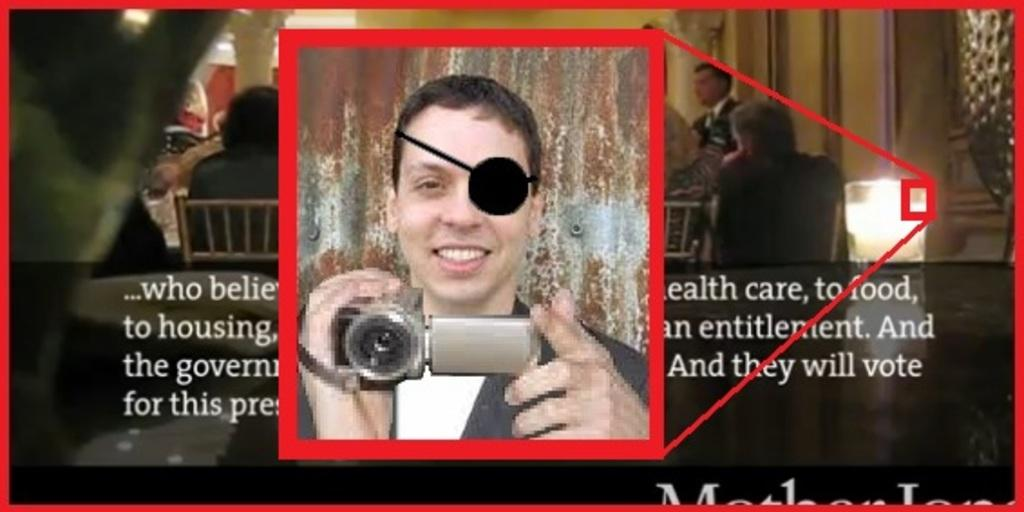What is the main object in the image? There is a poster in the image. What is depicted on the poster? The poster contains an image of a man holding a camera. Are there any other people visible in the image besides the man on the poster? Yes, there are people visible in the image. What else can be found on the poster besides the image of the man holding a camera? There is text on the poster. What type of turkey is being prepared by the people in the image? There is no turkey present in the image, nor is there any indication of food preparation. What sense is being emphasized in the image? The image does not emphasize any particular sense; it primarily features a poster with an image of a man holding a camera and some text. 